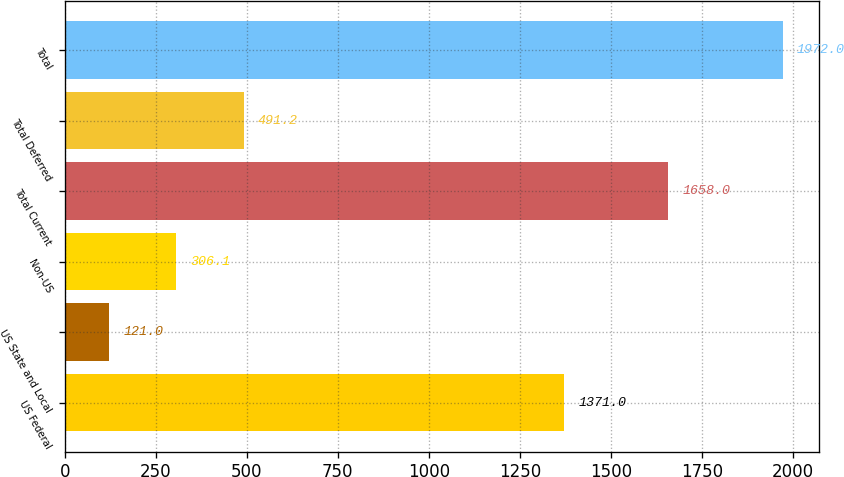Convert chart. <chart><loc_0><loc_0><loc_500><loc_500><bar_chart><fcel>US Federal<fcel>US State and Local<fcel>Non-US<fcel>Total Current<fcel>Total Deferred<fcel>Total<nl><fcel>1371<fcel>121<fcel>306.1<fcel>1658<fcel>491.2<fcel>1972<nl></chart> 